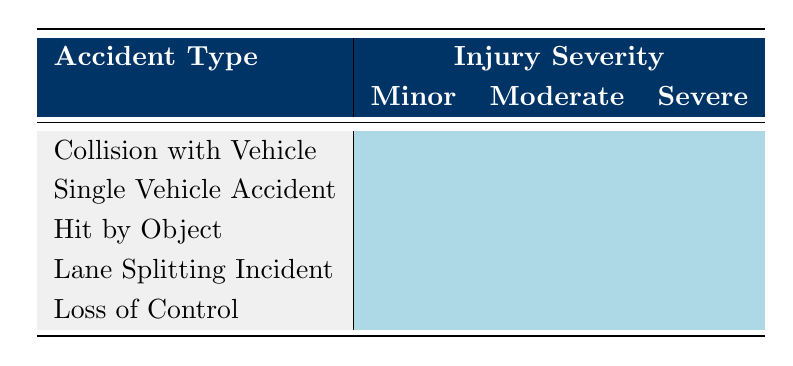What is the total number of accident types represented in the table? There are five distinct accident types listed in the table: Collision with Vehicle, Single Vehicle Accident, Hit by Object, Lane Splitting Incident, and Loss of Control.
Answer: 5 Which accident type has the highest number of severe injuries? All accident types listed have a category for severe injuries, but the table does not provide specific counts to compare them directly. Therefore, one cannot determine which has the highest without additional data.
Answer: Cannot Determine Is there a type of accident that has no moderate injuries listed? The table lists all accident types as having entries in all three categories of injury severity (Minor, Moderate, Severe). Hence, there is no accident type without moderate injuries.
Answer: No What is the relationship between "Single Vehicle Accident" and its injury severity when compared to "Hit by Object"? The injury severities for both types include all three categories: Minor, Moderate, and Severe, without indicating a greater frequency or severity for one over the other in the available data.
Answer: Equal distribution in severities How many total severe injuries are represented across all accident types? The table indicates that there are three injury severity categories for each of the five accident types. Therefore, there are a total of three severe injuries listed for each accident type, which sums to 15 across all categories.
Answer: 15 Which accident types show severe injuries only? The table indicates that all accident types have entries for each level of injury severity, so none show only severe injuries; each type includes minor and moderate injuries as well.
Answer: None Does "Lane Splitting Incident" have any minor injuries listed? The table categorizes "Lane Splitting Incident" under minor injuries, indicating that it does have minor injuries listed.
Answer: Yes What can be concluded about the injury severity trends for motorcycle accidents according to the types listed? Each accident type displays injuries across all levels of severity, suggesting that motorcycle accidents can lead to various injury severities regardless of the accident type. This indicates a consistent risk associated with different kinds of accidents.
Answer: All types have varying severities 